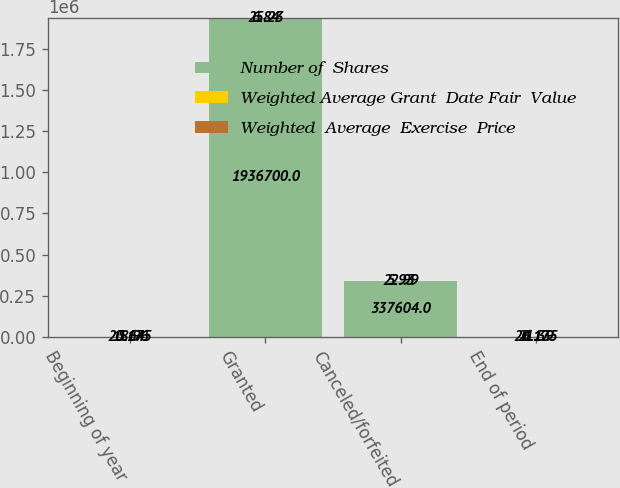Convert chart. <chart><loc_0><loc_0><loc_500><loc_500><stacked_bar_chart><ecel><fcel>Beginning of year<fcel>Granted<fcel>Canceled/forfeited<fcel>End of period<nl><fcel>Number of  Shares<fcel>20.175<fcel>1.9367e+06<fcel>337604<fcel>20.175<nl><fcel>Weighted Average Grant  Date Fair  Value<fcel>18.96<fcel>25.23<fcel>22.99<fcel>21.39<nl><fcel>Weighted  Average  Exercise  Price<fcel>5.64<fcel>6.84<fcel>5.93<fcel>6.13<nl></chart> 